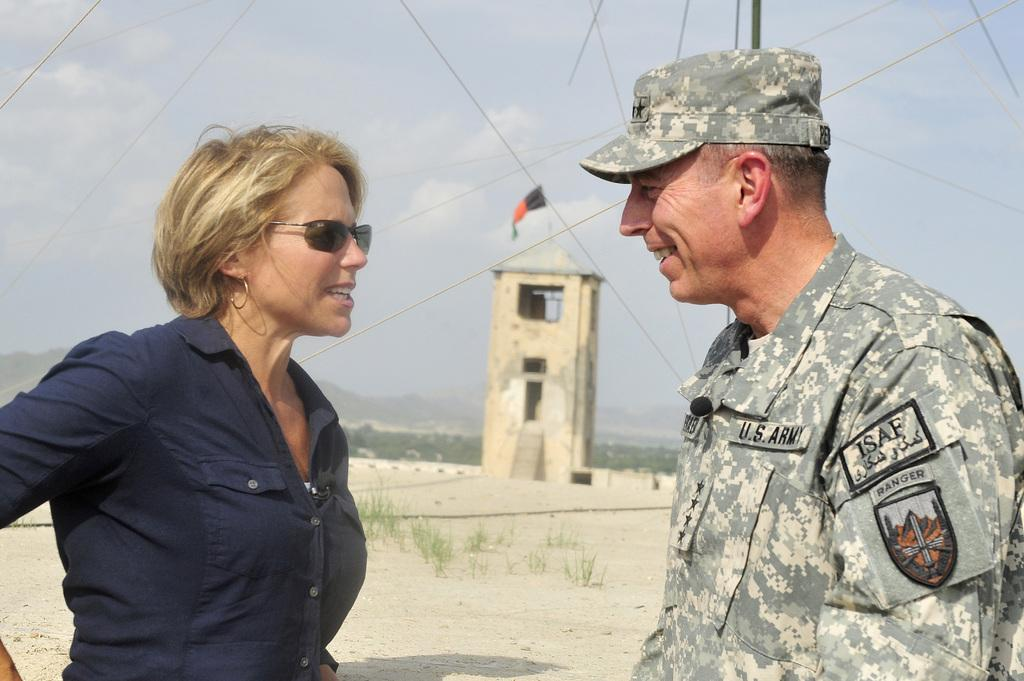What are the two persons in the image doing? The two persons in the image are standing and talking. What can be seen in the image besides the two persons? There is a tower with a flag above it, trees, and mountains in the background of the image. What type of book is the person holding in the image? There is no person holding a book in the image; the two persons are standing and talking. 